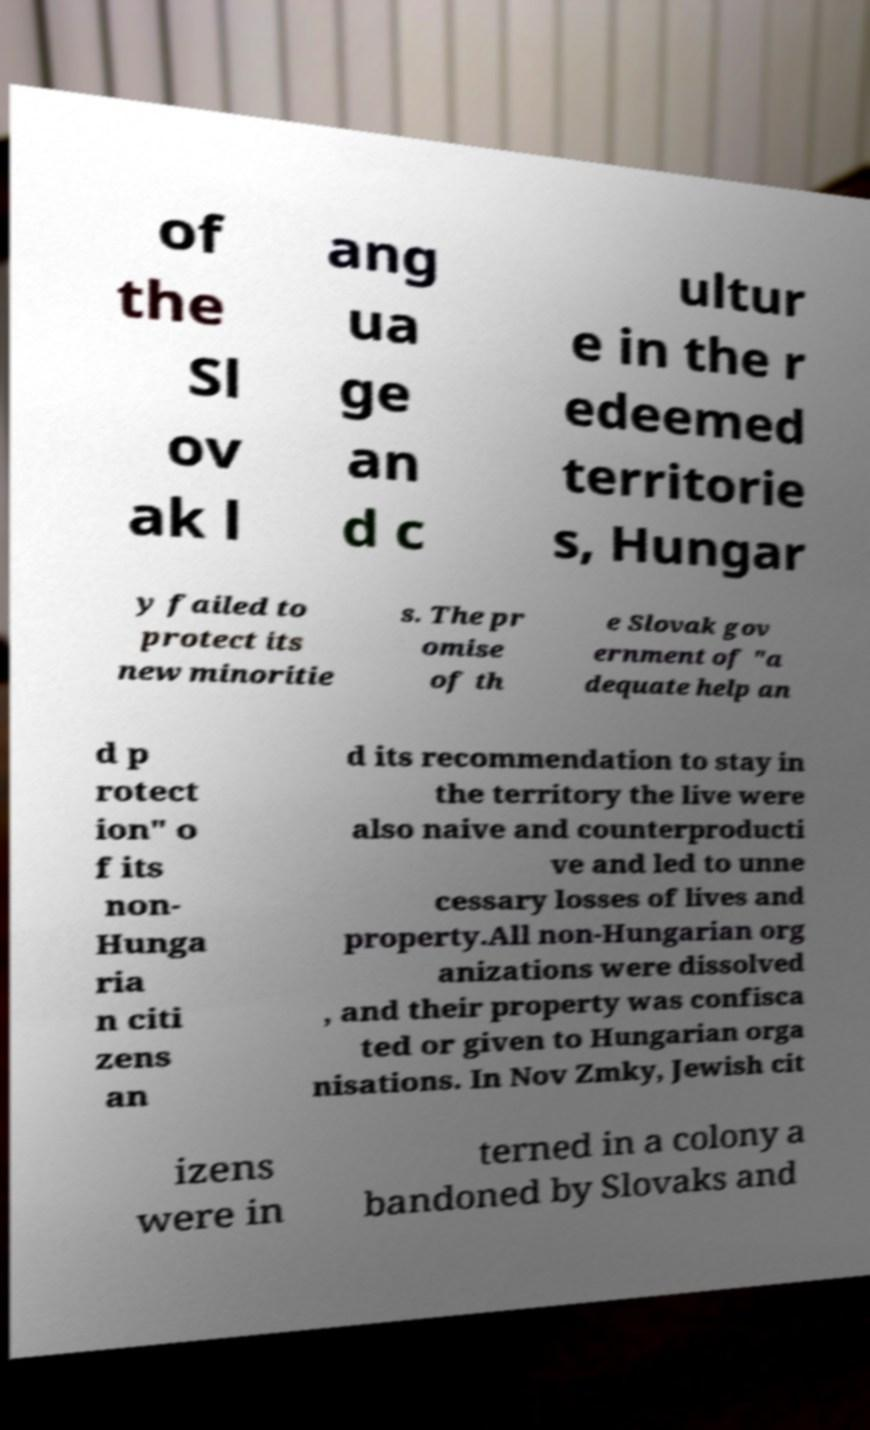Could you assist in decoding the text presented in this image and type it out clearly? of the Sl ov ak l ang ua ge an d c ultur e in the r edeemed territorie s, Hungar y failed to protect its new minoritie s. The pr omise of th e Slovak gov ernment of "a dequate help an d p rotect ion" o f its non- Hunga ria n citi zens an d its recommendation to stay in the territory the live were also naive and counterproducti ve and led to unne cessary losses of lives and property.All non-Hungarian org anizations were dissolved , and their property was confisca ted or given to Hungarian orga nisations. In Nov Zmky, Jewish cit izens were in terned in a colony a bandoned by Slovaks and 